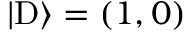<formula> <loc_0><loc_0><loc_500><loc_500>| D \rangle = ( 1 , 0 )</formula> 